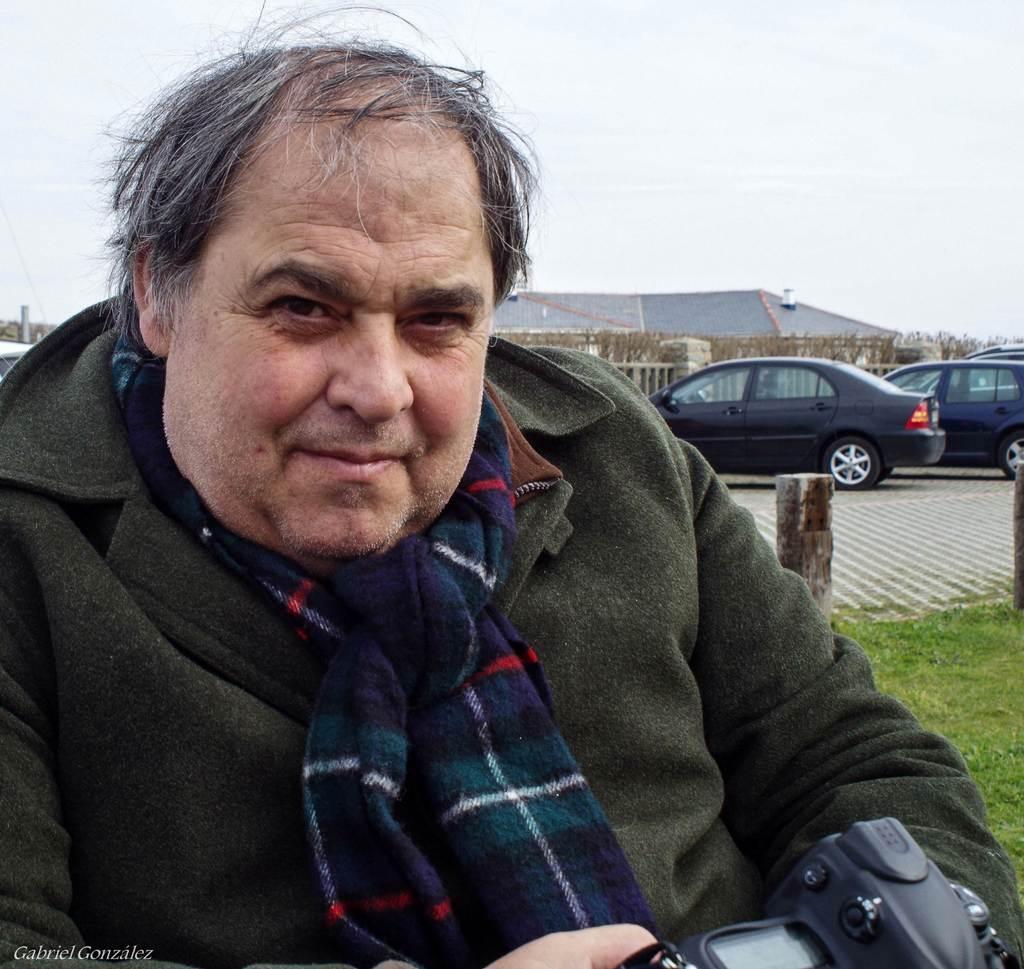Please provide a concise description of this image. This man wore jacket, scarf and holds a camera. Far there are vehicles, building, fence and trees. Grass is in green color. 